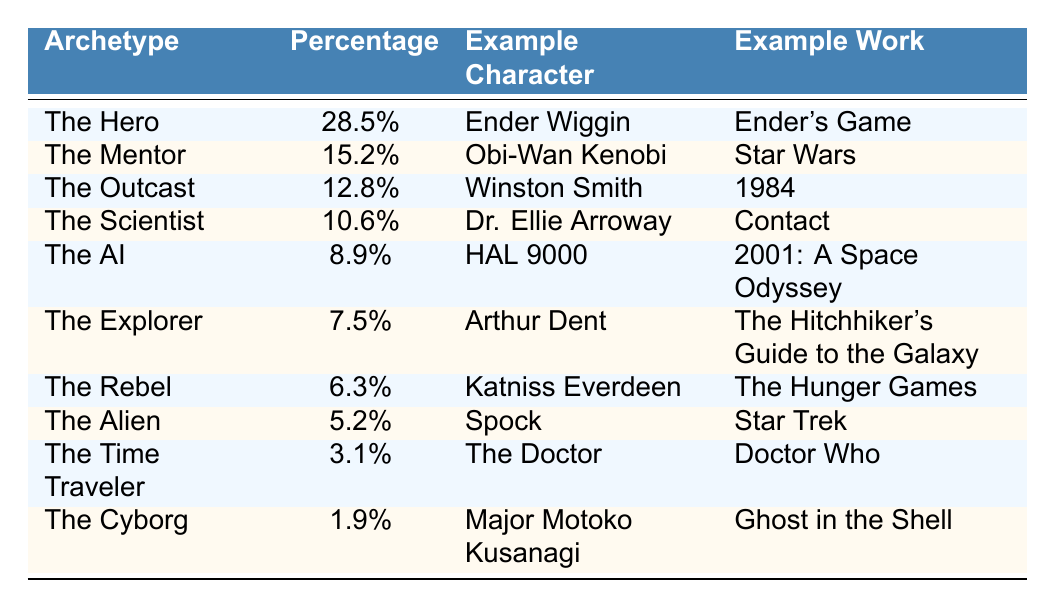What is the percentage of "The Hero" archetype? The table indicates that "The Hero" archetype has a percentage of 28.5%.
Answer: 28.5% Which character is associated with "The Mentor" archetype? The table states that Obi-Wan Kenobi is the example character for "The Mentor" archetype.
Answer: Obi-Wan Kenobi How many archetypes have a percentage greater than 10%? The archetypes with percentages greater than 10% are: The Hero (28.5%), The Mentor (15.2%), The Outcast (12.8%), and The Scientist (10.6%). This totals to 4 archetypes.
Answer: 4 What is the total percentage of "The AI" and "The Cyborg" archetypes combined? "The AI" has a percentage of 8.9% and "The Cyborg" has a percentage of 1.9%. Adding these gives 8.9% + 1.9% = 10.8% combined.
Answer: 10.8% Is "The Explorer" archetype more or less than 8%? The table shows that "The Explorer" has a percentage of 7.5%, which is less than 8%.
Answer: Less What percentage of characters are classified as either "The Rebel" or "The Alien"? "The Rebel" has 6.3% and "The Alien" has 5.2%. Adding these percentages gives 6.3% + 5.2% = 11.5%.
Answer: 11.5% Which archetype has the lowest percentage and what is that percentage? The table shows that "The Cyborg" has the lowest percentage at 1.9%.
Answer: The Cyborg, 1.9% If we consider only the top three archetypes, what is their average percentage? The top three archetypes are: The Hero (28.5%), The Mentor (15.2%), and The Outcast (12.8%). Their total percentage is 28.5% + 15.2% + 12.8% = 56.5%. Dividing by 3 gives an average of 18.83%.
Answer: 18.83% Are there any archetypes listed that specifically represent time travel? Yes, "The Time Traveler" archetype is specifically mentioned as having the character "The Doctor" and a percentage of 3.1%.
Answer: Yes Can you find three archetypes that have a percentage higher than "The Explorer"? "The Hero" (28.5%), "The Mentor" (15.2%), and "The Outcast" (12.8%) all have percentages higher than "The Explorer," which is 7.5%.
Answer: Yes 